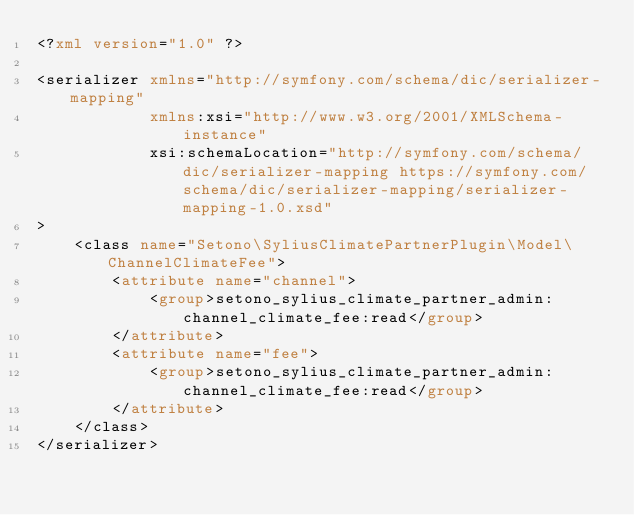Convert code to text. <code><loc_0><loc_0><loc_500><loc_500><_XML_><?xml version="1.0" ?>

<serializer xmlns="http://symfony.com/schema/dic/serializer-mapping"
            xmlns:xsi="http://www.w3.org/2001/XMLSchema-instance"
            xsi:schemaLocation="http://symfony.com/schema/dic/serializer-mapping https://symfony.com/schema/dic/serializer-mapping/serializer-mapping-1.0.xsd"
>
    <class name="Setono\SyliusClimatePartnerPlugin\Model\ChannelClimateFee">
        <attribute name="channel">
            <group>setono_sylius_climate_partner_admin:channel_climate_fee:read</group>
        </attribute>
        <attribute name="fee">
            <group>setono_sylius_climate_partner_admin:channel_climate_fee:read</group>
        </attribute>
    </class>
</serializer>
</code> 